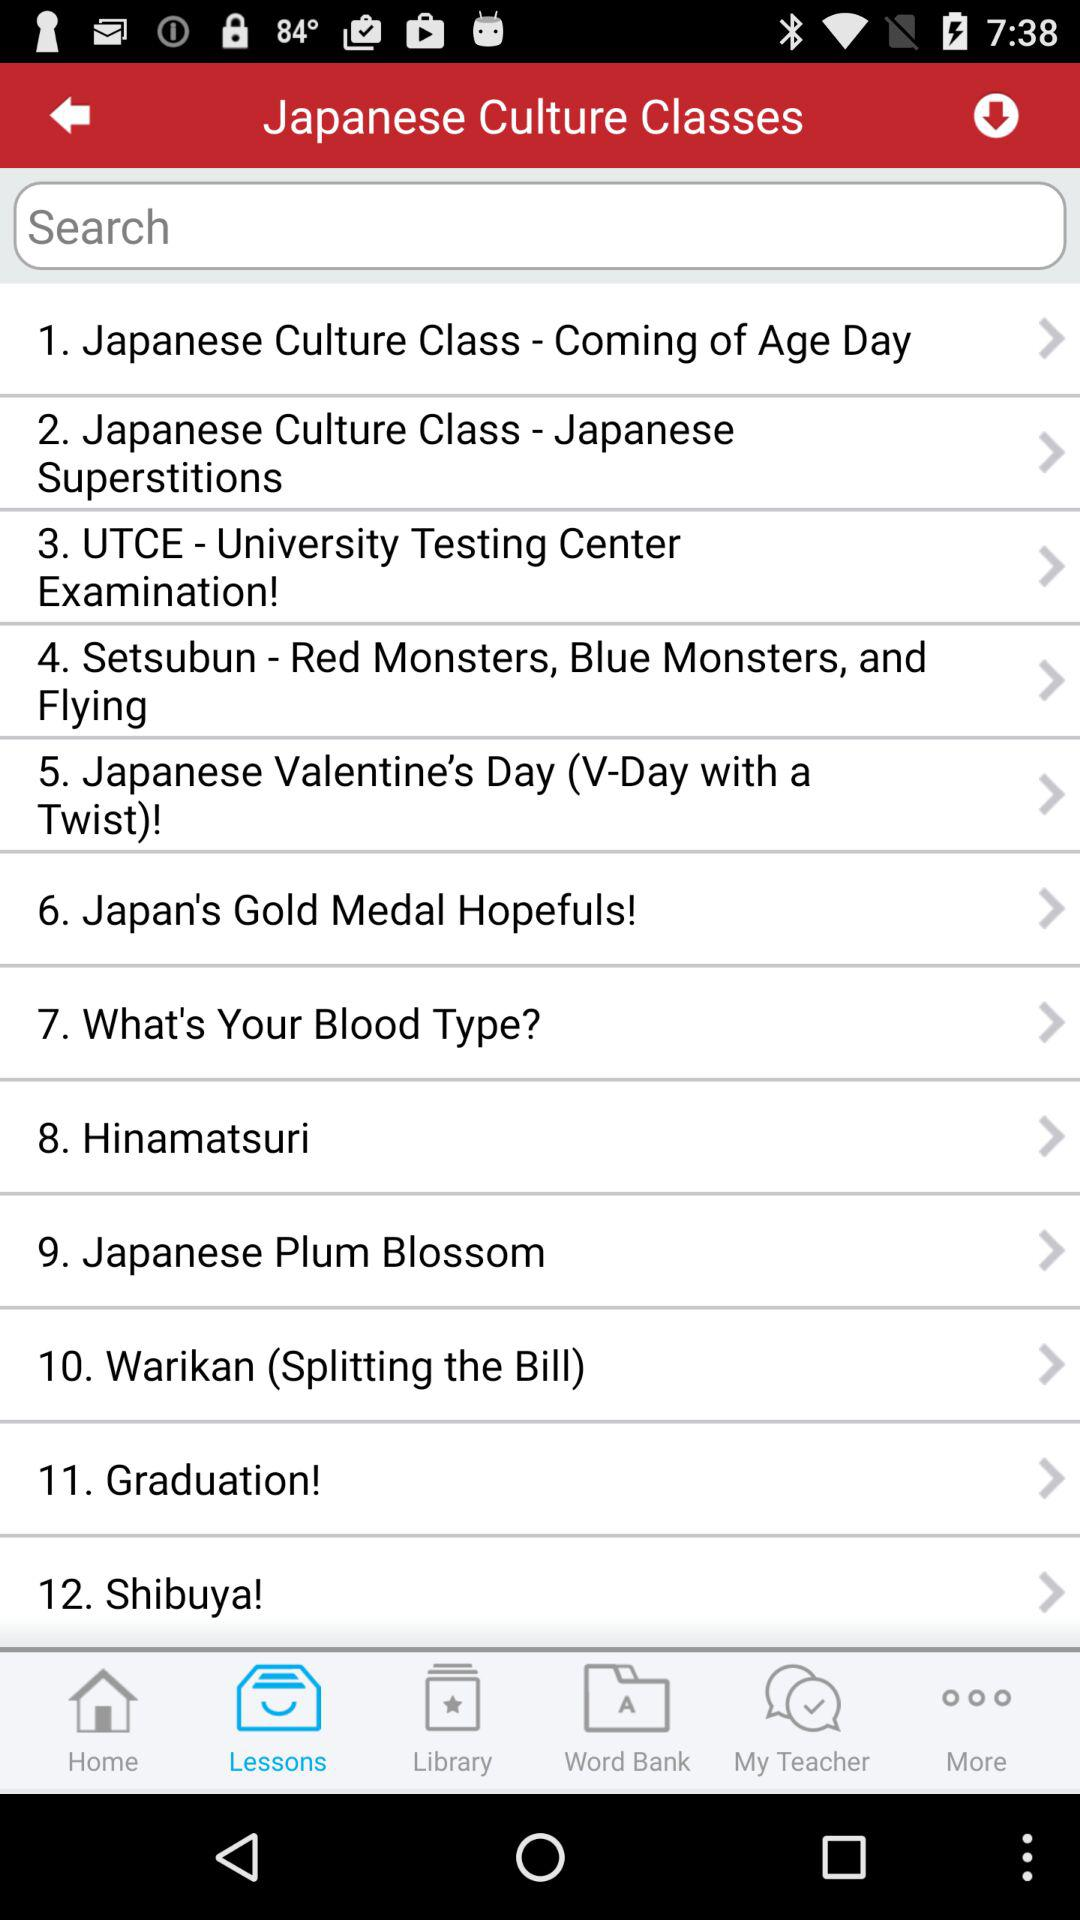What is the full form of UTCE in "Japanese Culture Classes"? The full form of UTCE in Japanese Culture Classes is "University Testing Center Examination". 